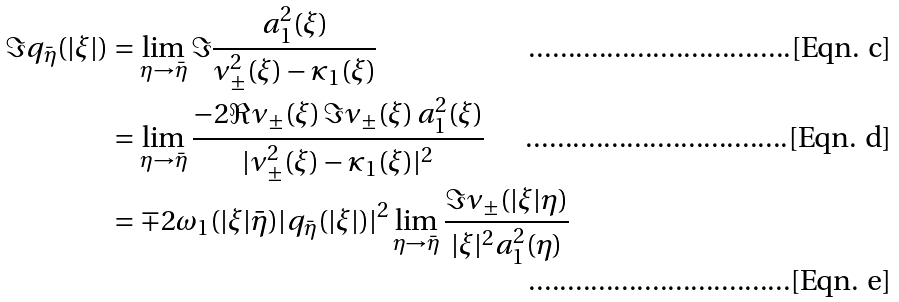Convert formula to latex. <formula><loc_0><loc_0><loc_500><loc_500>\Im q _ { \bar { \eta } } ( | \xi | ) & = \lim _ { \eta \to \bar { \eta } } \Im \frac { a _ { 1 } ^ { 2 } ( \xi ) } { \nu ^ { 2 } _ { \pm } ( \xi ) - \varkappa _ { 1 } ( \xi ) } \\ & = \lim _ { \eta \to \bar { \eta } } \frac { - 2 \Re \nu _ { \pm } ( \xi ) \, \Im \nu _ { \pm } ( \xi ) \, a _ { 1 } ^ { 2 } ( \xi ) } { | \nu ^ { 2 } _ { \pm } ( \xi ) - \varkappa _ { 1 } ( \xi ) | ^ { 2 } } \\ & = \mp 2 \omega _ { 1 } ( | \xi | \bar { \eta } ) | q _ { \bar { \eta } } ( | \xi | ) | ^ { 2 } \lim _ { \eta \to \bar { \eta } } \frac { \Im \nu _ { \pm } ( | \xi | \eta ) } { | \xi | ^ { 2 } a _ { 1 } ^ { 2 } ( \eta ) }</formula> 